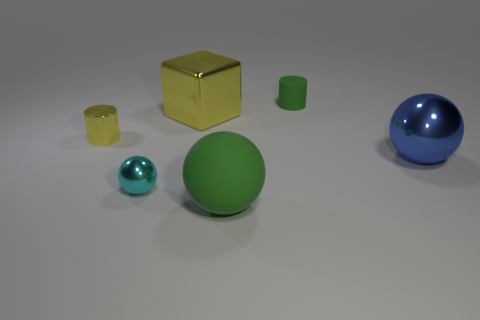How many objects are present in this image, and can you categorize them by their shape? In this image, there are five objects. They can be categorized into two spheres, two cubes, and one cylinder.  Are there any shadows indicating a light source in this scene? Yes, there are subtle shadows under each object, indicating that there is a light source above the scene, slightly off to the left. 